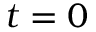<formula> <loc_0><loc_0><loc_500><loc_500>t = 0</formula> 